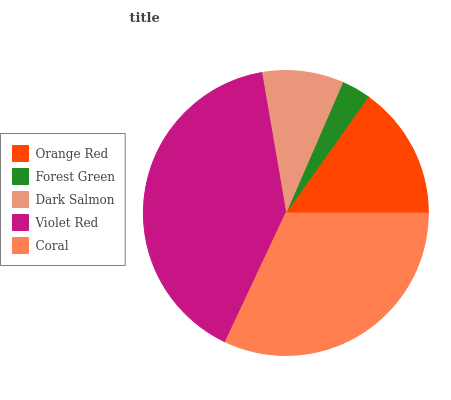Is Forest Green the minimum?
Answer yes or no. Yes. Is Violet Red the maximum?
Answer yes or no. Yes. Is Dark Salmon the minimum?
Answer yes or no. No. Is Dark Salmon the maximum?
Answer yes or no. No. Is Dark Salmon greater than Forest Green?
Answer yes or no. Yes. Is Forest Green less than Dark Salmon?
Answer yes or no. Yes. Is Forest Green greater than Dark Salmon?
Answer yes or no. No. Is Dark Salmon less than Forest Green?
Answer yes or no. No. Is Orange Red the high median?
Answer yes or no. Yes. Is Orange Red the low median?
Answer yes or no. Yes. Is Forest Green the high median?
Answer yes or no. No. Is Violet Red the low median?
Answer yes or no. No. 